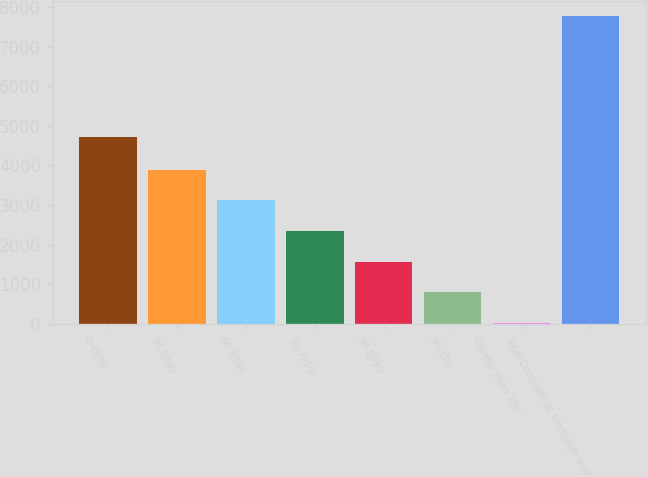<chart> <loc_0><loc_0><loc_500><loc_500><bar_chart><fcel>0-4999<fcel>50-5999<fcel>60-6999<fcel>70-7999<fcel>80-8999<fcel>90-100<fcel>Greater than 100<fcel>Total Commercial Mortgage and<nl><fcel>4710<fcel>3894.5<fcel>3118.8<fcel>2343.1<fcel>1567.4<fcel>791.7<fcel>16<fcel>7773<nl></chart> 